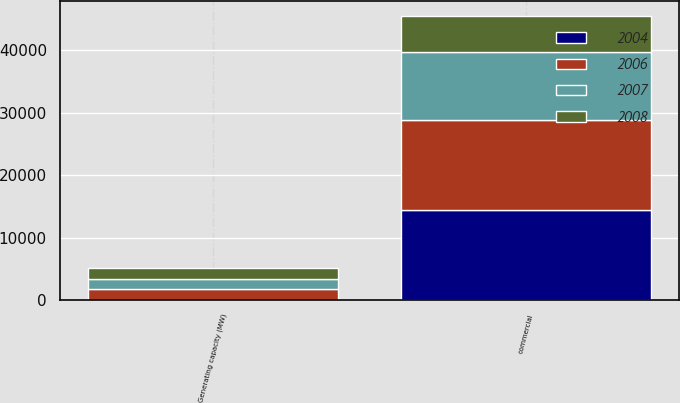Convert chart. <chart><loc_0><loc_0><loc_500><loc_500><stacked_bar_chart><ecel><fcel>Generating capacity (MW)<fcel>commercial<nl><fcel>2004<fcel>21<fcel>14491<nl><fcel>2006<fcel>1739<fcel>14335<nl><fcel>2007<fcel>1668<fcel>10957<nl><fcel>2008<fcel>1668<fcel>5775<nl></chart> 